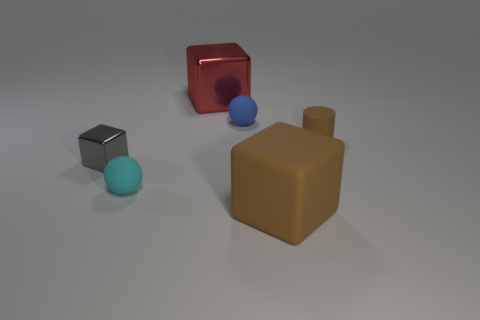There is a matte cylinder; does it have the same size as the metallic object to the left of the red metallic block?
Offer a very short reply. Yes. What is the color of the cylinder?
Offer a very short reply. Brown. The matte thing that is right of the large object in front of the rubber ball in front of the small brown matte object is what shape?
Make the answer very short. Cylinder. The big cube that is to the left of the thing in front of the small cyan rubber sphere is made of what material?
Provide a short and direct response. Metal. What shape is the large brown thing that is the same material as the cyan sphere?
Your response must be concise. Cube. Is there anything else that has the same shape as the big red thing?
Offer a terse response. Yes. What number of small cylinders are in front of the gray shiny cube?
Ensure brevity in your answer.  0. Is there a blue thing?
Keep it short and to the point. Yes. There is a ball that is behind the brown rubber thing behind the big block that is to the right of the big metallic thing; what is its color?
Provide a succinct answer. Blue. There is a large red metallic block that is to the right of the tiny gray block; is there a thing that is in front of it?
Provide a succinct answer. Yes. 